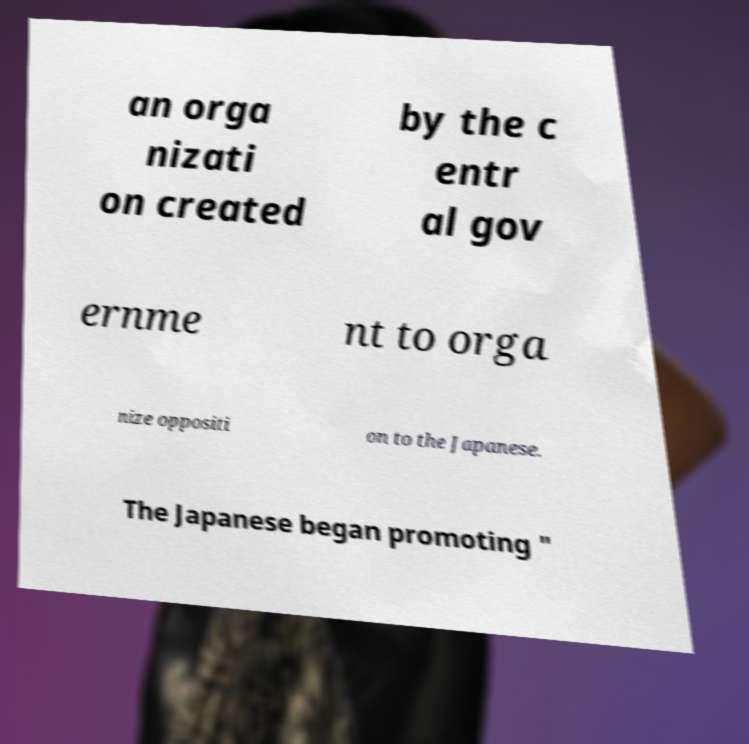Could you assist in decoding the text presented in this image and type it out clearly? an orga nizati on created by the c entr al gov ernme nt to orga nize oppositi on to the Japanese. The Japanese began promoting " 